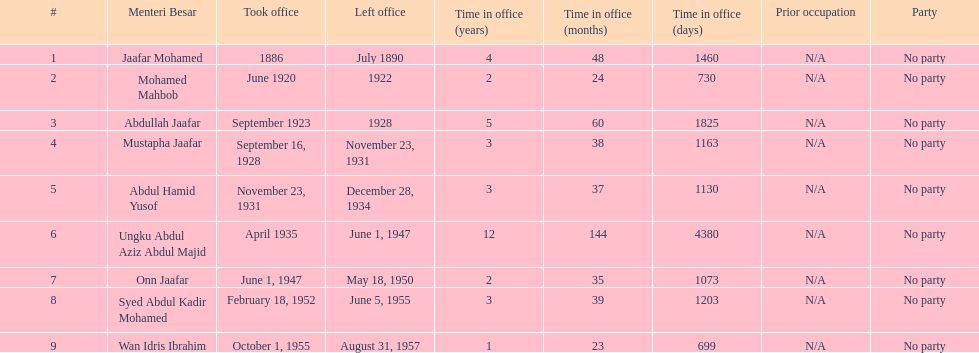Who is listed below onn jaafar? Syed Abdul Kadir Mohamed. 